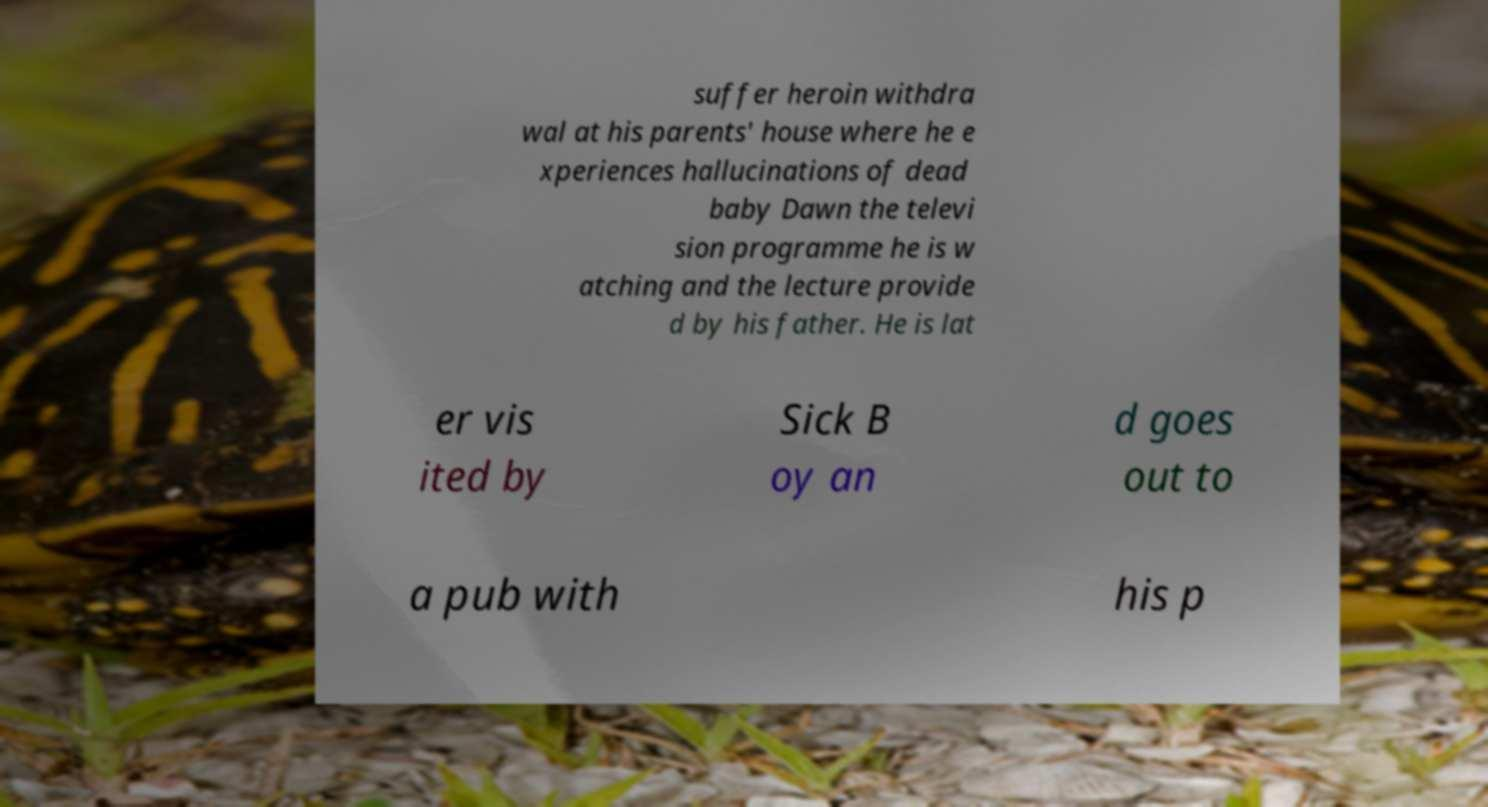What messages or text are displayed in this image? I need them in a readable, typed format. suffer heroin withdra wal at his parents' house where he e xperiences hallucinations of dead baby Dawn the televi sion programme he is w atching and the lecture provide d by his father. He is lat er vis ited by Sick B oy an d goes out to a pub with his p 